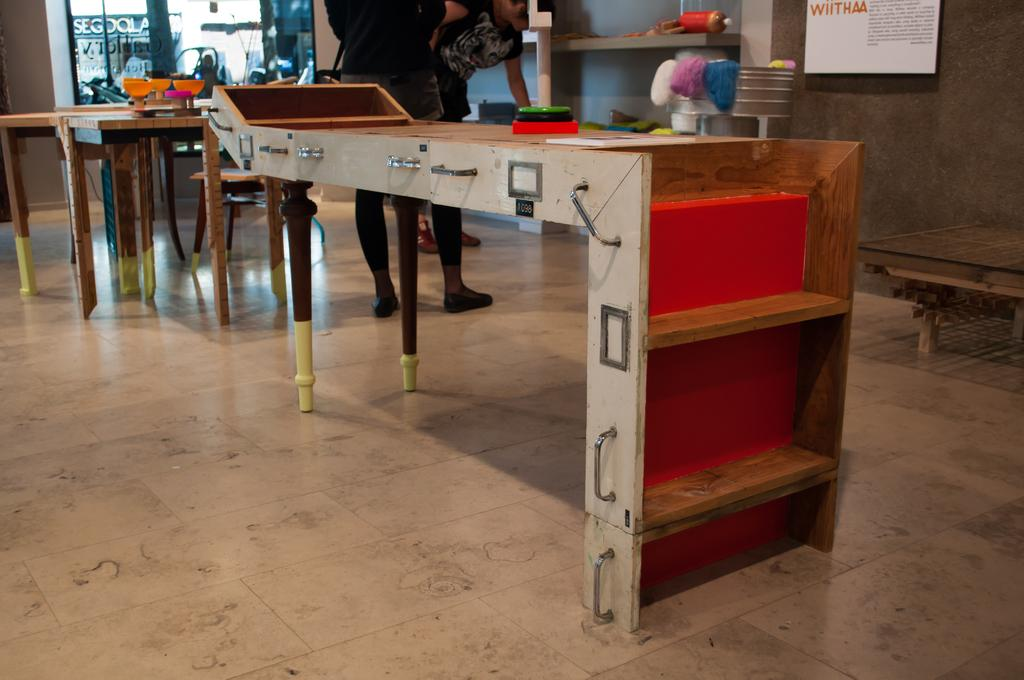How many people are in the image? There are two persons in the image. What are the persons doing in the image? The persons are standing near a table. What can be seen on the table in the image? There are many items on the table. What type of side dish is being smashed on the table in the image? There is no side dish being smashed on the table in the image. What level of detail can be seen on the items on the table in the image? The level of detail on the items on the table cannot be determined from the image, as the facts do not provide information about the items' appearance. 